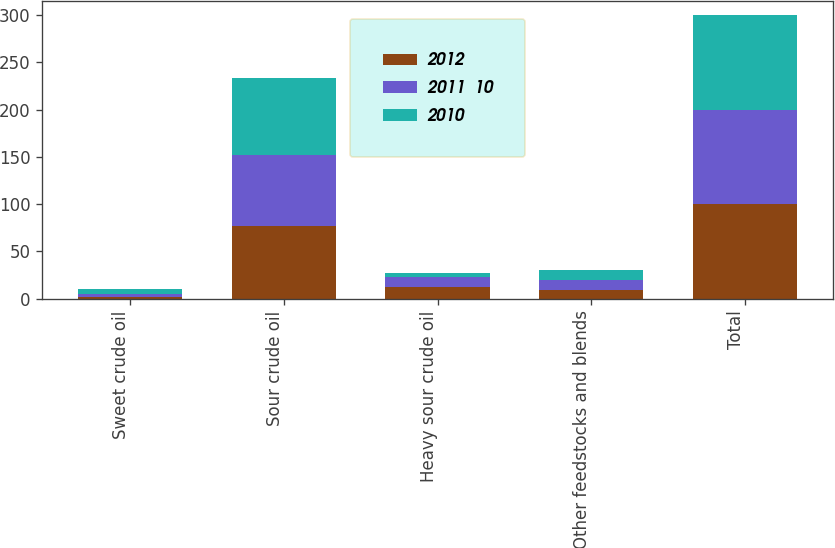Convert chart. <chart><loc_0><loc_0><loc_500><loc_500><stacked_bar_chart><ecel><fcel>Sweet crude oil<fcel>Sour crude oil<fcel>Heavy sour crude oil<fcel>Other feedstocks and blends<fcel>Total<nl><fcel>2012<fcel>2<fcel>77<fcel>12<fcel>9<fcel>100<nl><fcel>2011  10<fcel>3<fcel>75<fcel>11<fcel>11<fcel>100<nl><fcel>2010<fcel>5<fcel>81<fcel>4<fcel>10<fcel>100<nl></chart> 